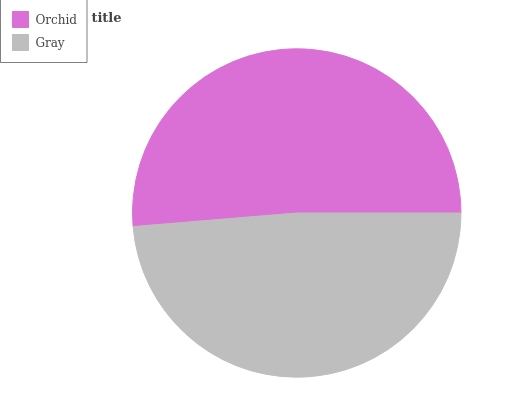Is Gray the minimum?
Answer yes or no. Yes. Is Orchid the maximum?
Answer yes or no. Yes. Is Gray the maximum?
Answer yes or no. No. Is Orchid greater than Gray?
Answer yes or no. Yes. Is Gray less than Orchid?
Answer yes or no. Yes. Is Gray greater than Orchid?
Answer yes or no. No. Is Orchid less than Gray?
Answer yes or no. No. Is Orchid the high median?
Answer yes or no. Yes. Is Gray the low median?
Answer yes or no. Yes. Is Gray the high median?
Answer yes or no. No. Is Orchid the low median?
Answer yes or no. No. 